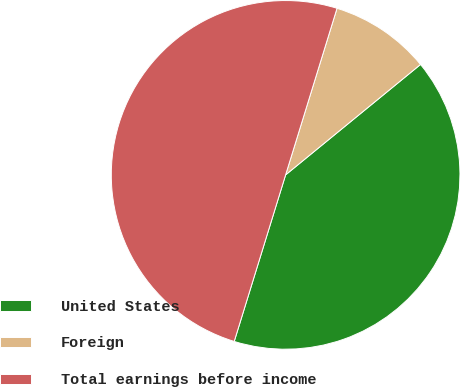<chart> <loc_0><loc_0><loc_500><loc_500><pie_chart><fcel>United States<fcel>Foreign<fcel>Total earnings before income<nl><fcel>40.68%<fcel>9.32%<fcel>50.0%<nl></chart> 